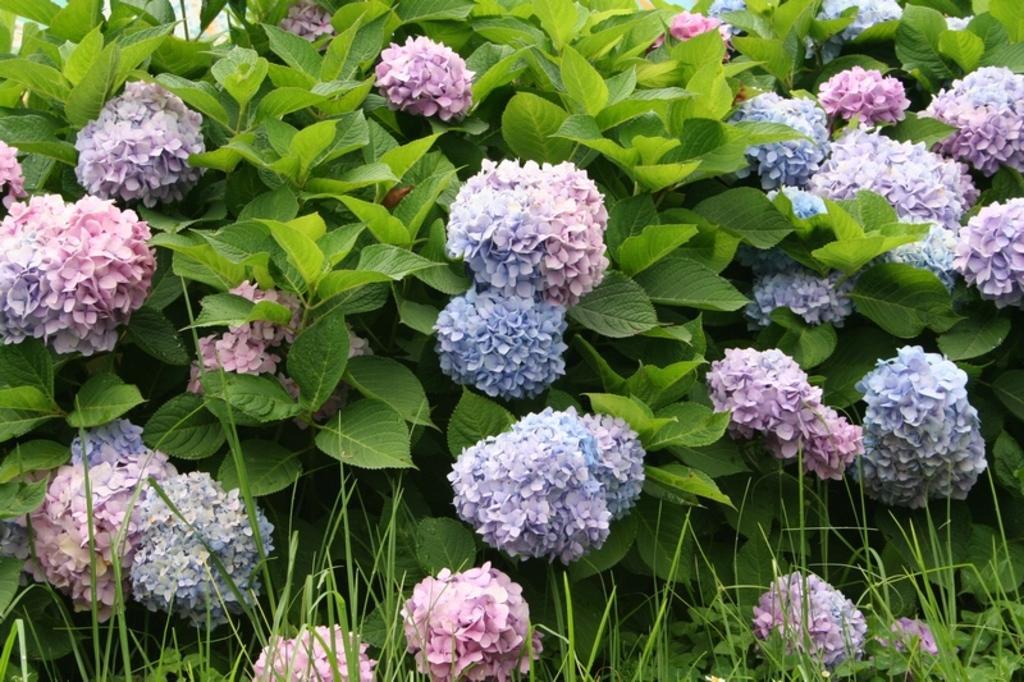Could you give a brief overview of what you see in this image? In this image we can see blue and pink color flowers to the plants and here we can see the grass. 